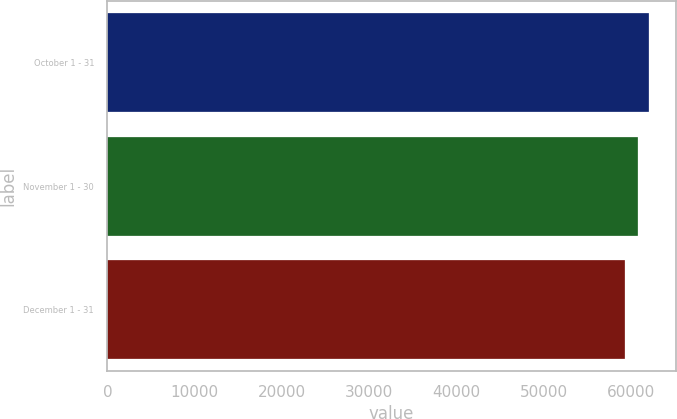Convert chart to OTSL. <chart><loc_0><loc_0><loc_500><loc_500><bar_chart><fcel>October 1 - 31<fcel>November 1 - 30<fcel>December 1 - 31<nl><fcel>61962<fcel>60719<fcel>59270<nl></chart> 